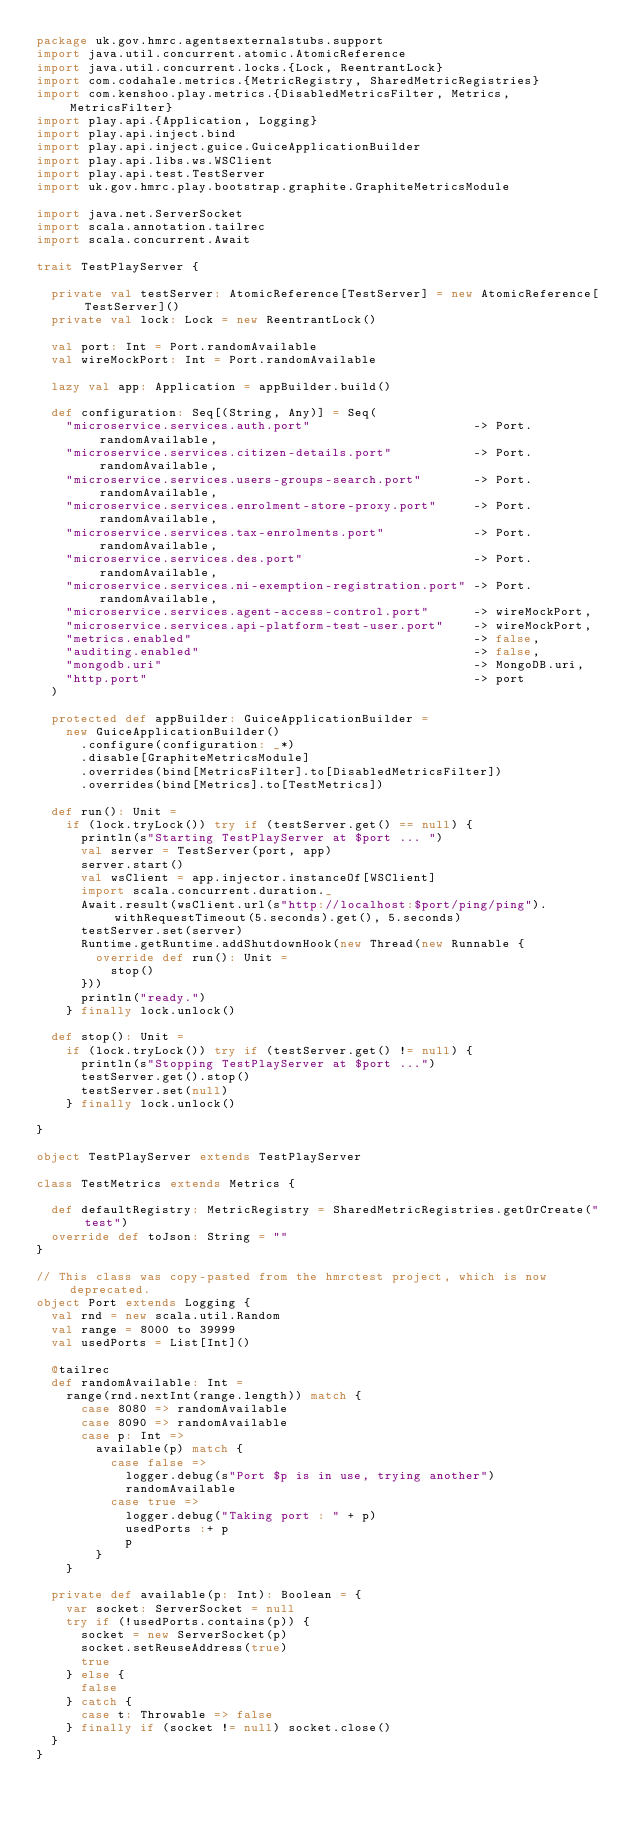<code> <loc_0><loc_0><loc_500><loc_500><_Scala_>package uk.gov.hmrc.agentsexternalstubs.support
import java.util.concurrent.atomic.AtomicReference
import java.util.concurrent.locks.{Lock, ReentrantLock}
import com.codahale.metrics.{MetricRegistry, SharedMetricRegistries}
import com.kenshoo.play.metrics.{DisabledMetricsFilter, Metrics, MetricsFilter}
import play.api.{Application, Logging}
import play.api.inject.bind
import play.api.inject.guice.GuiceApplicationBuilder
import play.api.libs.ws.WSClient
import play.api.test.TestServer
import uk.gov.hmrc.play.bootstrap.graphite.GraphiteMetricsModule

import java.net.ServerSocket
import scala.annotation.tailrec
import scala.concurrent.Await

trait TestPlayServer {

  private val testServer: AtomicReference[TestServer] = new AtomicReference[TestServer]()
  private val lock: Lock = new ReentrantLock()

  val port: Int = Port.randomAvailable
  val wireMockPort: Int = Port.randomAvailable

  lazy val app: Application = appBuilder.build()

  def configuration: Seq[(String, Any)] = Seq(
    "microservice.services.auth.port"                      -> Port.randomAvailable,
    "microservice.services.citizen-details.port"           -> Port.randomAvailable,
    "microservice.services.users-groups-search.port"       -> Port.randomAvailable,
    "microservice.services.enrolment-store-proxy.port"     -> Port.randomAvailable,
    "microservice.services.tax-enrolments.port"            -> Port.randomAvailable,
    "microservice.services.des.port"                       -> Port.randomAvailable,
    "microservice.services.ni-exemption-registration.port" -> Port.randomAvailable,
    "microservice.services.agent-access-control.port"      -> wireMockPort,
    "microservice.services.api-platform-test-user.port"    -> wireMockPort,
    "metrics.enabled"                                      -> false,
    "auditing.enabled"                                     -> false,
    "mongodb.uri"                                          -> MongoDB.uri,
    "http.port"                                            -> port
  )

  protected def appBuilder: GuiceApplicationBuilder =
    new GuiceApplicationBuilder()
      .configure(configuration: _*)
      .disable[GraphiteMetricsModule]
      .overrides(bind[MetricsFilter].to[DisabledMetricsFilter])
      .overrides(bind[Metrics].to[TestMetrics])

  def run(): Unit =
    if (lock.tryLock()) try if (testServer.get() == null) {
      println(s"Starting TestPlayServer at $port ... ")
      val server = TestServer(port, app)
      server.start()
      val wsClient = app.injector.instanceOf[WSClient]
      import scala.concurrent.duration._
      Await.result(wsClient.url(s"http://localhost:$port/ping/ping").withRequestTimeout(5.seconds).get(), 5.seconds)
      testServer.set(server)
      Runtime.getRuntime.addShutdownHook(new Thread(new Runnable {
        override def run(): Unit =
          stop()
      }))
      println("ready.")
    } finally lock.unlock()

  def stop(): Unit =
    if (lock.tryLock()) try if (testServer.get() != null) {
      println(s"Stopping TestPlayServer at $port ...")
      testServer.get().stop()
      testServer.set(null)
    } finally lock.unlock()

}

object TestPlayServer extends TestPlayServer

class TestMetrics extends Metrics {

  def defaultRegistry: MetricRegistry = SharedMetricRegistries.getOrCreate("test")
  override def toJson: String = ""
}

// This class was copy-pasted from the hmrctest project, which is now deprecated.
object Port extends Logging {
  val rnd = new scala.util.Random
  val range = 8000 to 39999
  val usedPorts = List[Int]()

  @tailrec
  def randomAvailable: Int =
    range(rnd.nextInt(range.length)) match {
      case 8080 => randomAvailable
      case 8090 => randomAvailable
      case p: Int =>
        available(p) match {
          case false =>
            logger.debug(s"Port $p is in use, trying another")
            randomAvailable
          case true =>
            logger.debug("Taking port : " + p)
            usedPorts :+ p
            p
        }
    }

  private def available(p: Int): Boolean = {
    var socket: ServerSocket = null
    try if (!usedPorts.contains(p)) {
      socket = new ServerSocket(p)
      socket.setReuseAddress(true)
      true
    } else {
      false
    } catch {
      case t: Throwable => false
    } finally if (socket != null) socket.close()
  }
}
</code> 